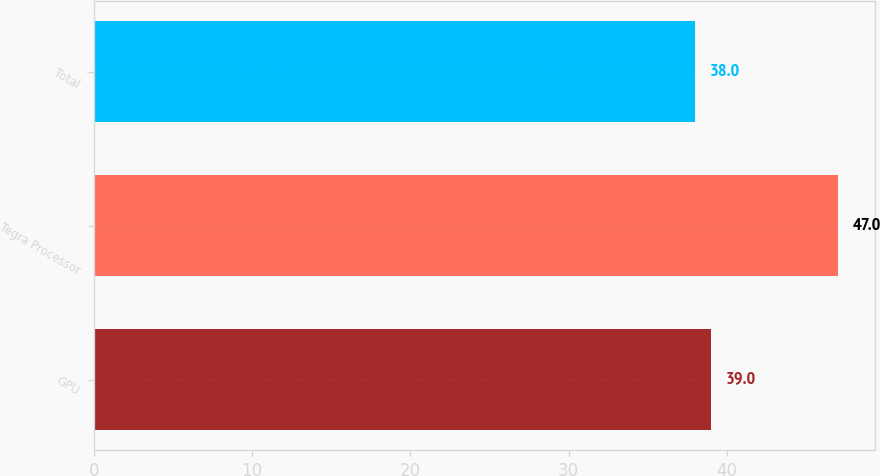<chart> <loc_0><loc_0><loc_500><loc_500><bar_chart><fcel>GPU<fcel>Tegra Processor<fcel>Total<nl><fcel>39<fcel>47<fcel>38<nl></chart> 